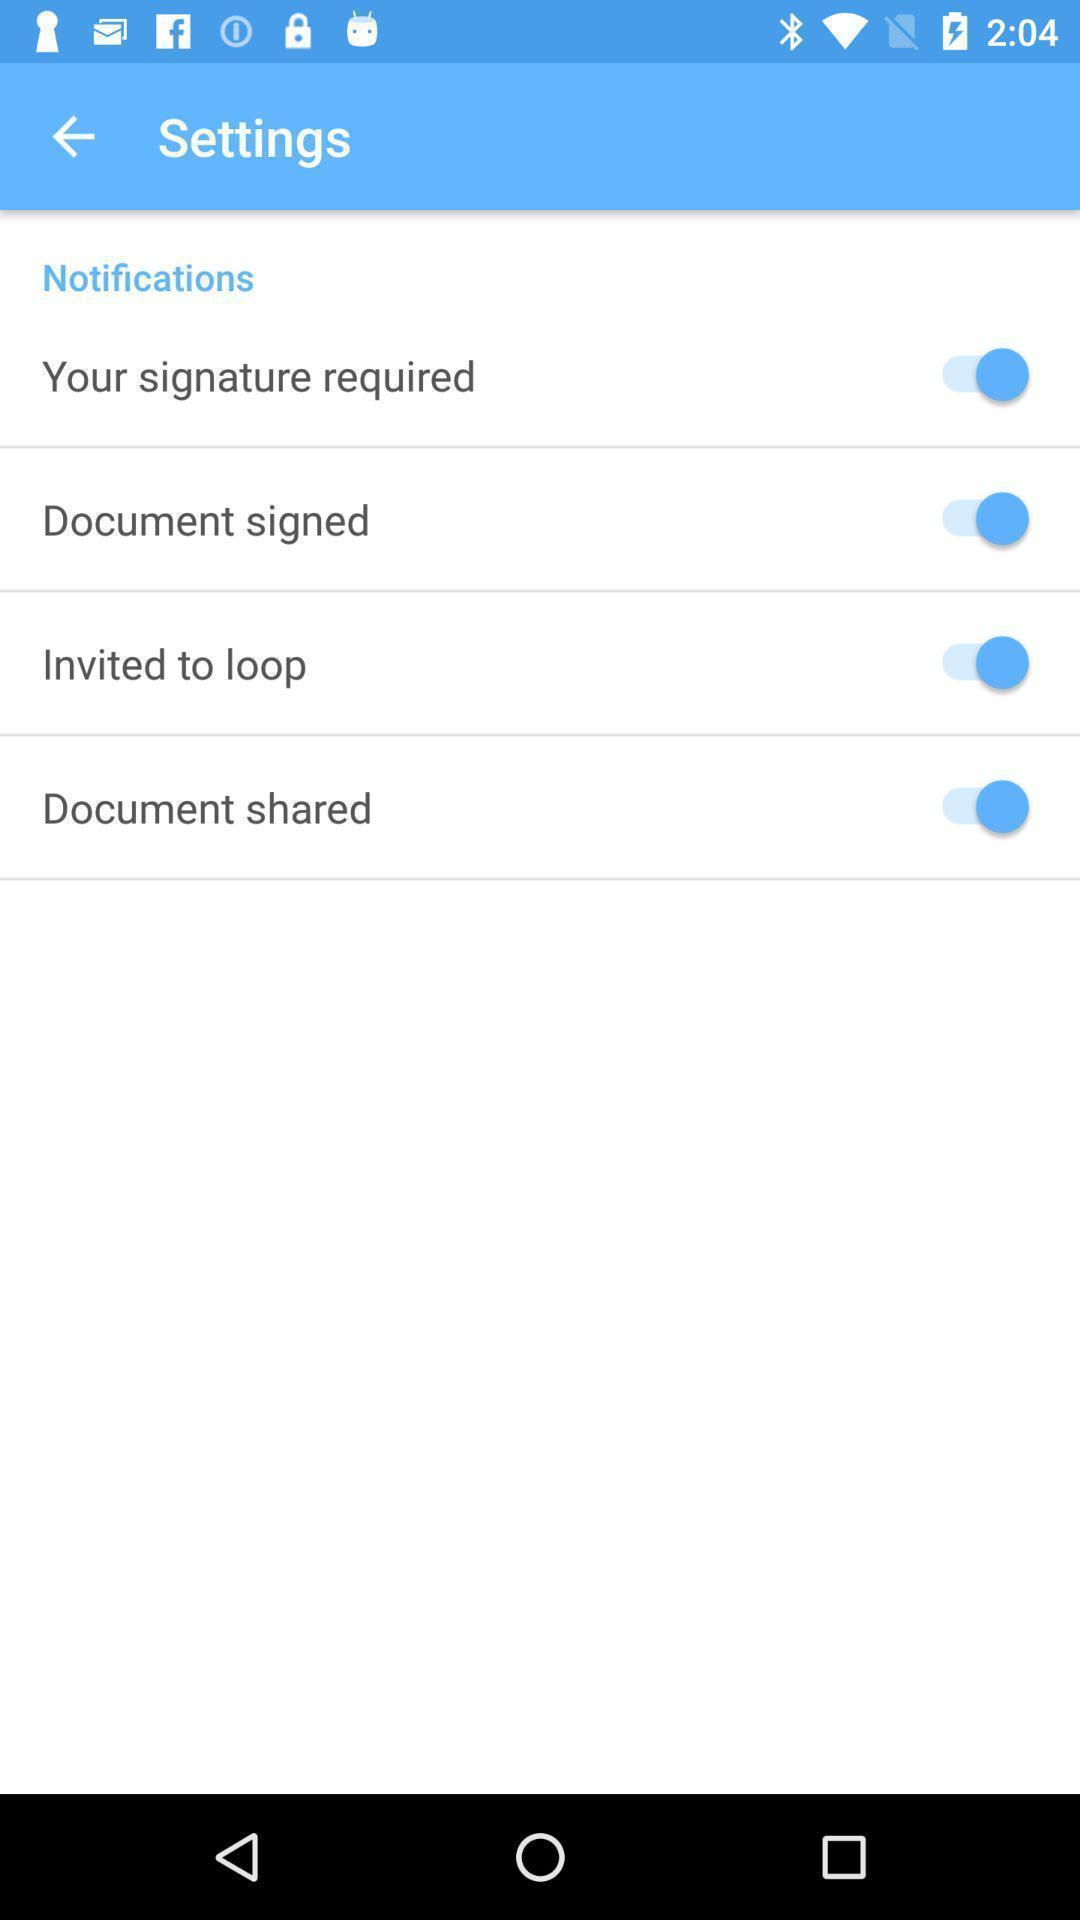Describe the content in this image. Screen shows settings. 